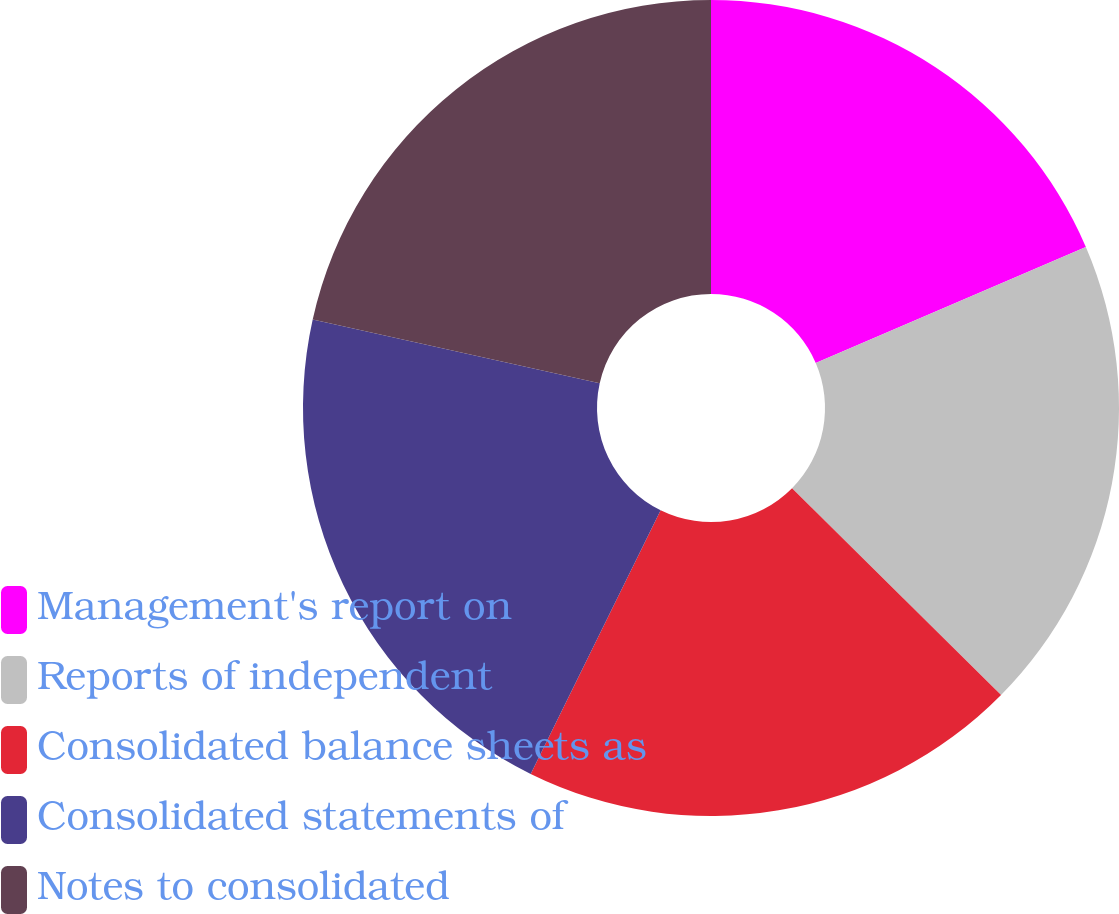Convert chart. <chart><loc_0><loc_0><loc_500><loc_500><pie_chart><fcel>Management's report on<fcel>Reports of independent<fcel>Consolidated balance sheets as<fcel>Consolidated statements of<fcel>Notes to consolidated<nl><fcel>18.54%<fcel>18.87%<fcel>19.87%<fcel>21.19%<fcel>21.52%<nl></chart> 